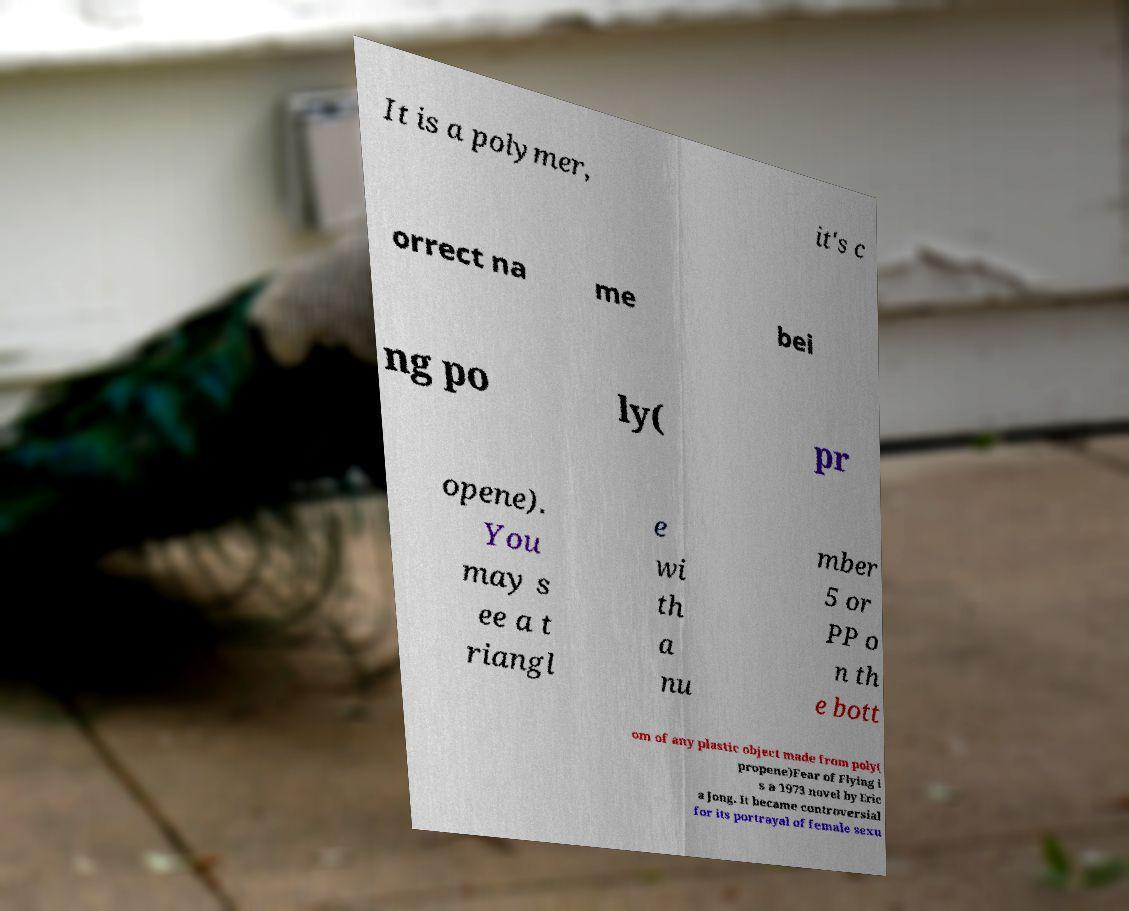There's text embedded in this image that I need extracted. Can you transcribe it verbatim? It is a polymer, it's c orrect na me bei ng po ly( pr opene). You may s ee a t riangl e wi th a nu mber 5 or PP o n th e bott om of any plastic object made from poly( propene)Fear of Flying i s a 1973 novel by Eric a Jong. It became controversial for its portrayal of female sexu 